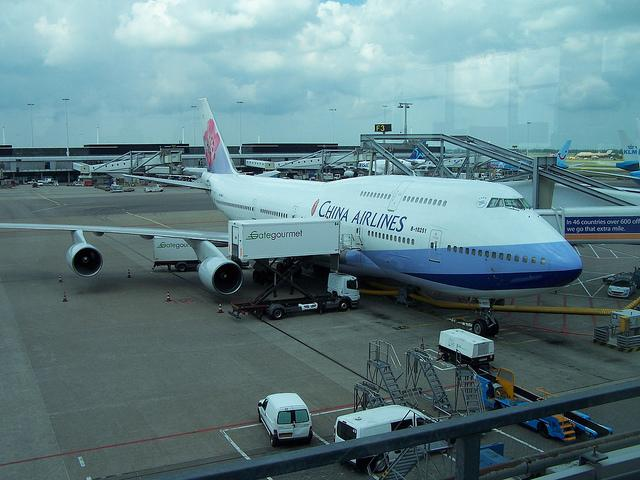How were the drivers of the cars able to park here? Please explain your reasoning. airport workers. These drivers work at the airport. 